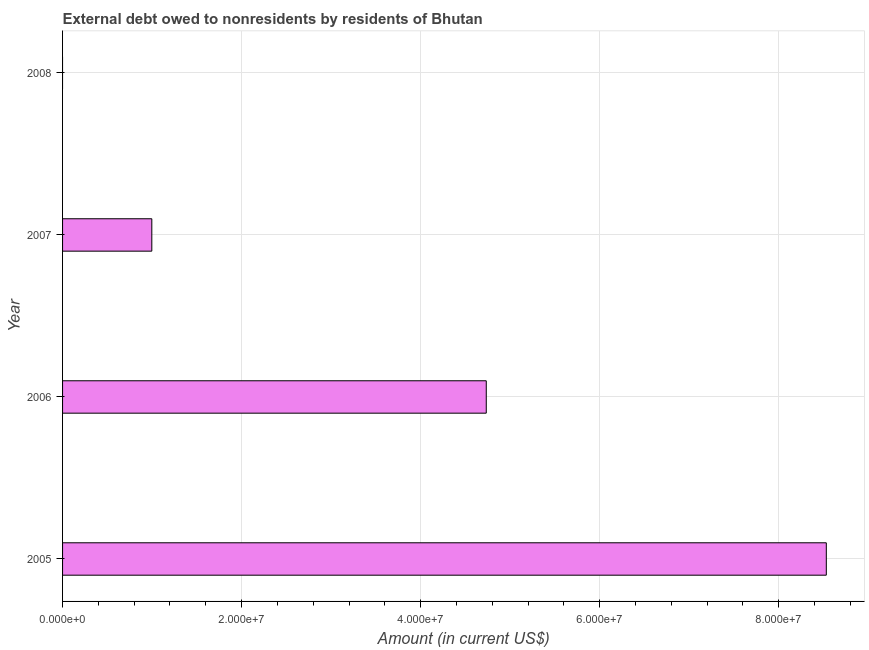What is the title of the graph?
Your answer should be very brief. External debt owed to nonresidents by residents of Bhutan. What is the label or title of the X-axis?
Provide a succinct answer. Amount (in current US$). What is the debt in 2005?
Ensure brevity in your answer.  8.53e+07. Across all years, what is the maximum debt?
Offer a very short reply. 8.53e+07. What is the sum of the debt?
Keep it short and to the point. 1.43e+08. What is the difference between the debt in 2005 and 2007?
Make the answer very short. 7.54e+07. What is the average debt per year?
Give a very brief answer. 3.57e+07. What is the median debt?
Ensure brevity in your answer.  2.87e+07. In how many years, is the debt greater than 44000000 US$?
Your answer should be compact. 2. What is the ratio of the debt in 2005 to that in 2007?
Ensure brevity in your answer.  8.56. What is the difference between the highest and the second highest debt?
Your answer should be very brief. 3.80e+07. What is the difference between the highest and the lowest debt?
Offer a very short reply. 8.53e+07. How many bars are there?
Make the answer very short. 3. What is the difference between two consecutive major ticks on the X-axis?
Provide a short and direct response. 2.00e+07. Are the values on the major ticks of X-axis written in scientific E-notation?
Your answer should be compact. Yes. What is the Amount (in current US$) in 2005?
Provide a short and direct response. 8.53e+07. What is the Amount (in current US$) in 2006?
Ensure brevity in your answer.  4.73e+07. What is the Amount (in current US$) of 2007?
Keep it short and to the point. 9.97e+06. What is the difference between the Amount (in current US$) in 2005 and 2006?
Ensure brevity in your answer.  3.80e+07. What is the difference between the Amount (in current US$) in 2005 and 2007?
Ensure brevity in your answer.  7.54e+07. What is the difference between the Amount (in current US$) in 2006 and 2007?
Provide a succinct answer. 3.74e+07. What is the ratio of the Amount (in current US$) in 2005 to that in 2006?
Your answer should be very brief. 1.8. What is the ratio of the Amount (in current US$) in 2005 to that in 2007?
Keep it short and to the point. 8.56. What is the ratio of the Amount (in current US$) in 2006 to that in 2007?
Provide a short and direct response. 4.75. 